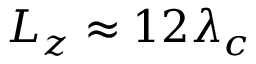<formula> <loc_0><loc_0><loc_500><loc_500>L _ { z } \approx 1 2 \lambda _ { c }</formula> 